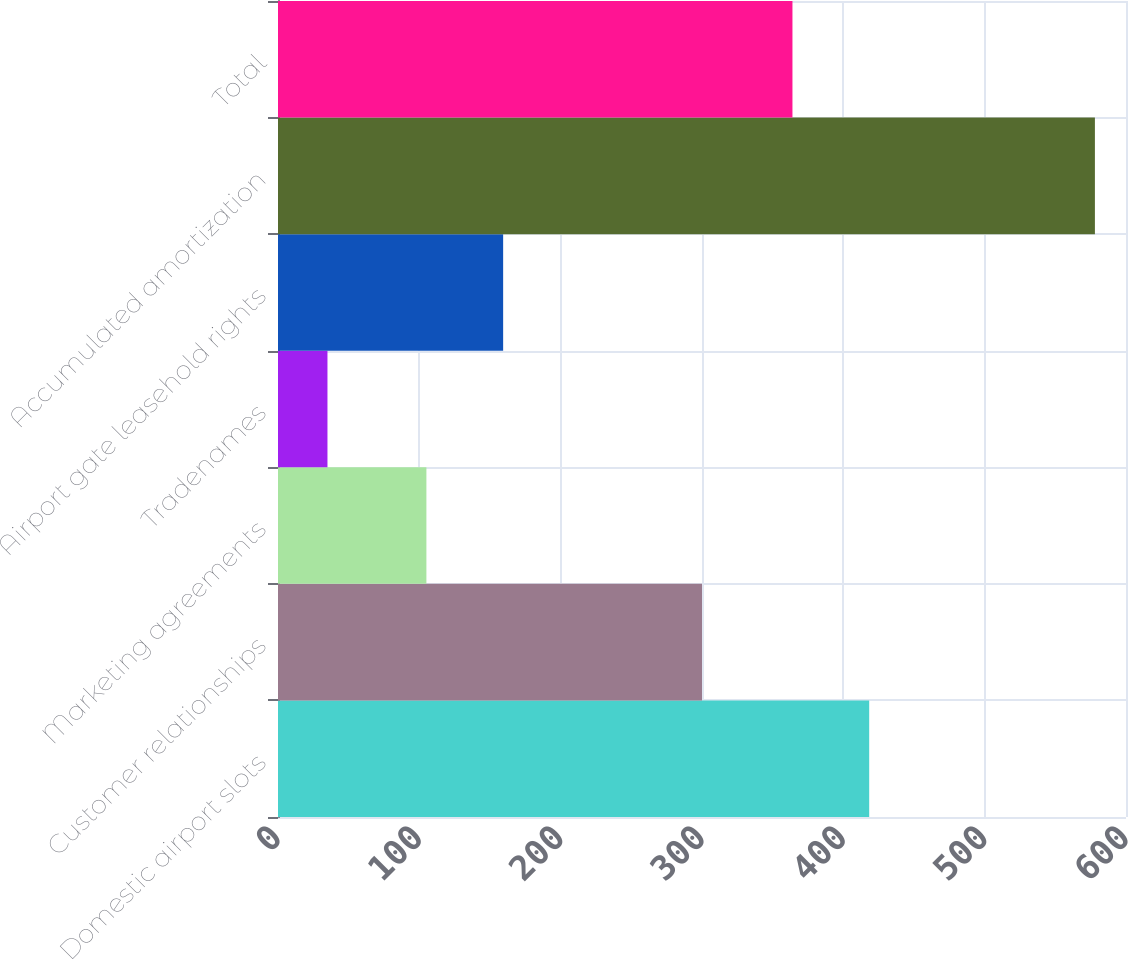<chart> <loc_0><loc_0><loc_500><loc_500><bar_chart><fcel>Domestic airport slots<fcel>Customer relationships<fcel>Marketing agreements<fcel>Tradenames<fcel>Airport gate leasehold rights<fcel>Accumulated amortization<fcel>Total<nl><fcel>418.3<fcel>300<fcel>105<fcel>35<fcel>159.3<fcel>578<fcel>364<nl></chart> 